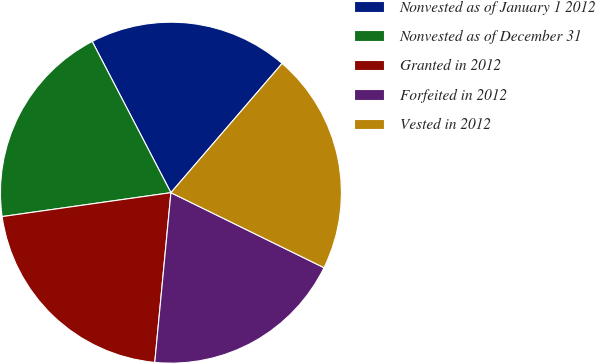Convert chart to OTSL. <chart><loc_0><loc_0><loc_500><loc_500><pie_chart><fcel>Nonvested as of January 1 2012<fcel>Nonvested as of December 31<fcel>Granted in 2012<fcel>Forfeited in 2012<fcel>Vested in 2012<nl><fcel>18.95%<fcel>19.6%<fcel>21.25%<fcel>19.26%<fcel>20.94%<nl></chart> 